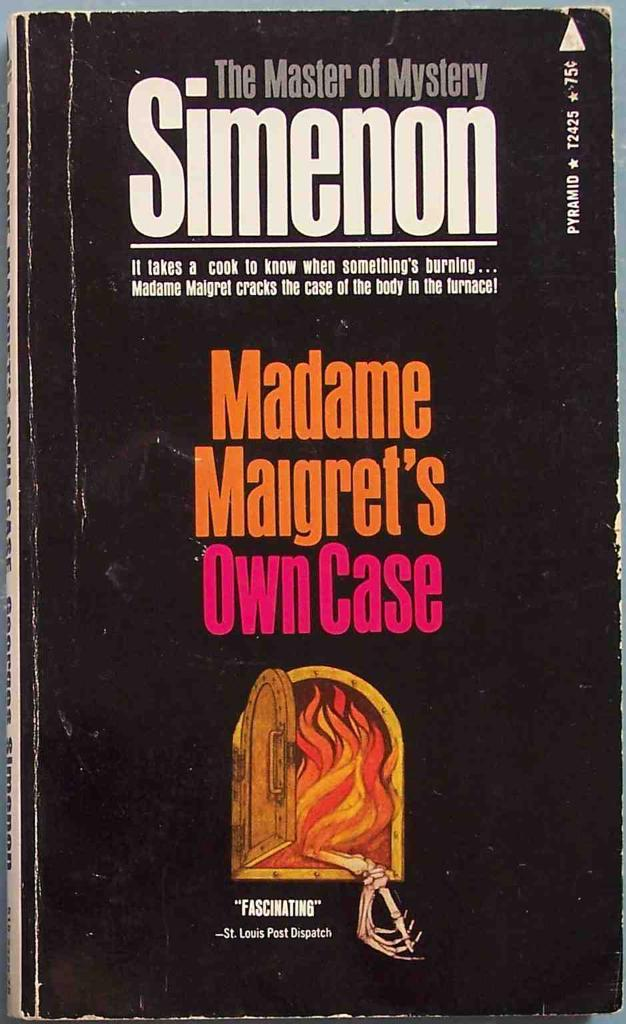<image>
Summarize the visual content of the image. A book called the master of mystery simenon Madame Margret's Own case 